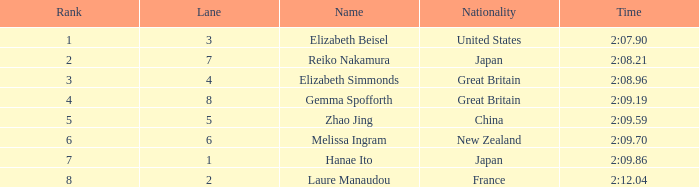What is Laure Manaudou's highest rank? 8.0. 